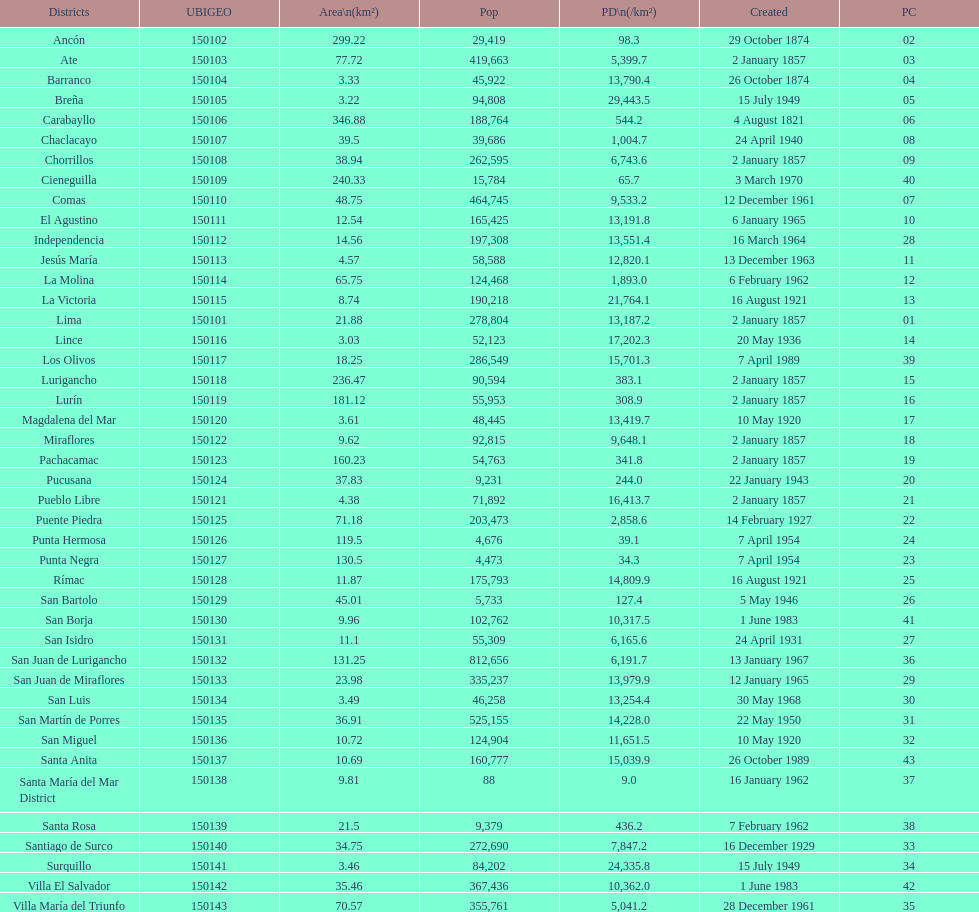What was the final district formed? Santa Anita. 